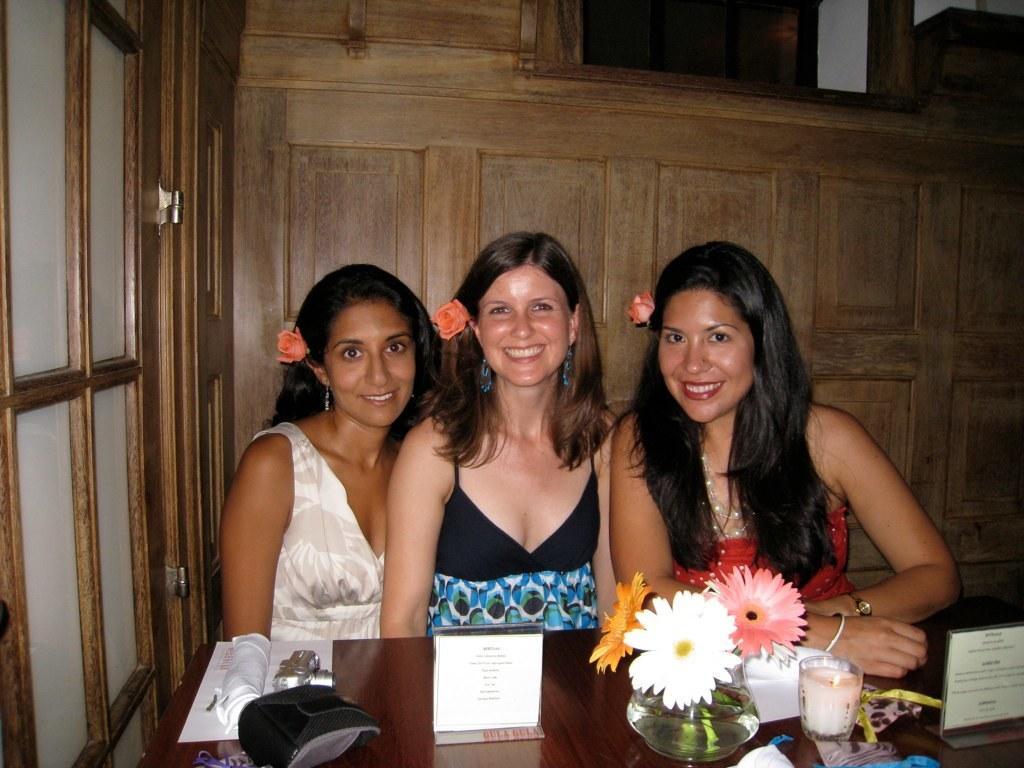Please provide a concise description of this image. In this image, there are a few people sitting. We can see a table with some objects like boards with text, flowers and a glass with some liquid. In the background, we can see the wooden wall. We can also see some glass on the left. 